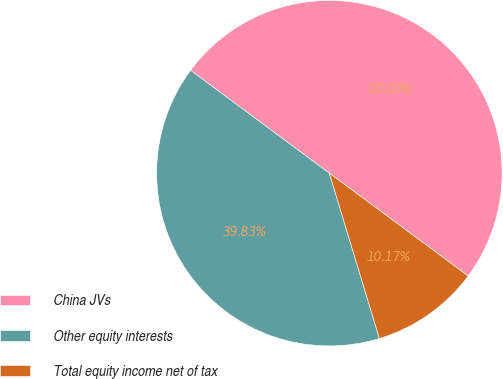<chart> <loc_0><loc_0><loc_500><loc_500><pie_chart><fcel>China JVs<fcel>Other equity interests<fcel>Total equity income net of tax<nl><fcel>50.0%<fcel>39.83%<fcel>10.17%<nl></chart> 